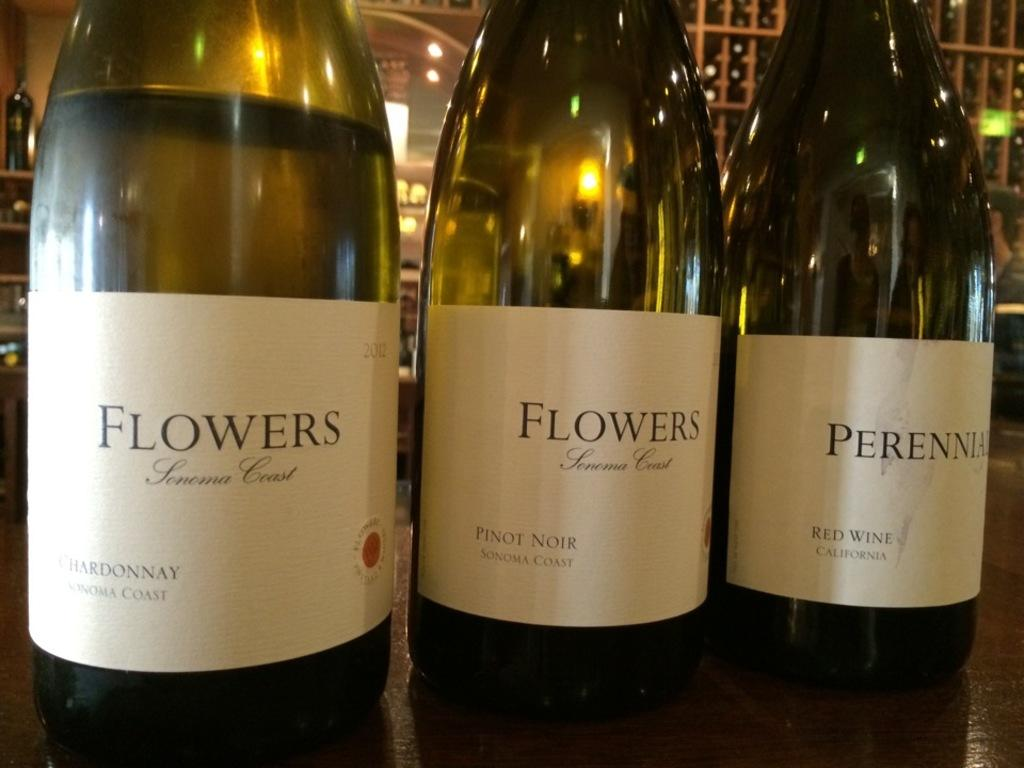<image>
Write a terse but informative summary of the picture. Three bottles sit on a table with two bottles with labels that read, "Flowers." 